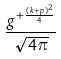Convert formula to latex. <formula><loc_0><loc_0><loc_500><loc_500>\frac { g ^ { + \frac { ( k + p ) ^ { 2 } } { 4 } } } { \sqrt { 4 \pi } }</formula> 